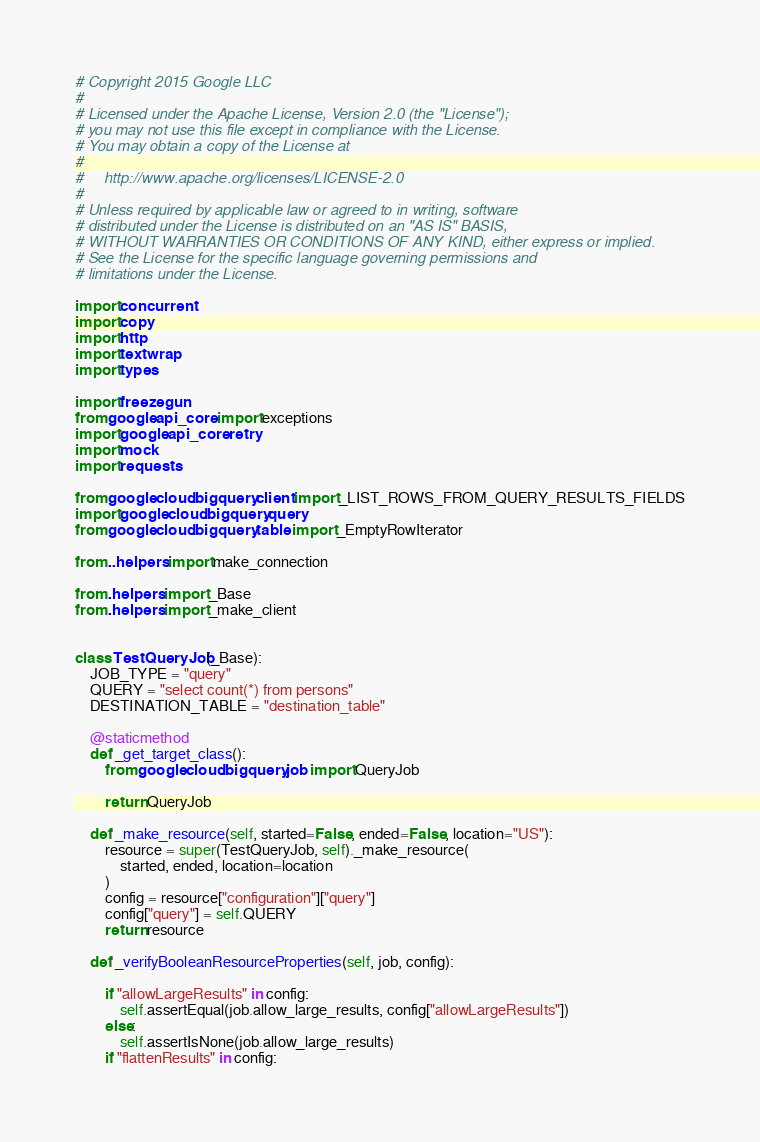<code> <loc_0><loc_0><loc_500><loc_500><_Python_># Copyright 2015 Google LLC
#
# Licensed under the Apache License, Version 2.0 (the "License");
# you may not use this file except in compliance with the License.
# You may obtain a copy of the License at
#
#     http://www.apache.org/licenses/LICENSE-2.0
#
# Unless required by applicable law or agreed to in writing, software
# distributed under the License is distributed on an "AS IS" BASIS,
# WITHOUT WARRANTIES OR CONDITIONS OF ANY KIND, either express or implied.
# See the License for the specific language governing permissions and
# limitations under the License.

import concurrent
import copy
import http
import textwrap
import types

import freezegun
from google.api_core import exceptions
import google.api_core.retry
import mock
import requests

from google.cloud.bigquery.client import _LIST_ROWS_FROM_QUERY_RESULTS_FIELDS
import google.cloud.bigquery.query
from google.cloud.bigquery.table import _EmptyRowIterator

from ..helpers import make_connection

from .helpers import _Base
from .helpers import _make_client


class TestQueryJob(_Base):
    JOB_TYPE = "query"
    QUERY = "select count(*) from persons"
    DESTINATION_TABLE = "destination_table"

    @staticmethod
    def _get_target_class():
        from google.cloud.bigquery.job import QueryJob

        return QueryJob

    def _make_resource(self, started=False, ended=False, location="US"):
        resource = super(TestQueryJob, self)._make_resource(
            started, ended, location=location
        )
        config = resource["configuration"]["query"]
        config["query"] = self.QUERY
        return resource

    def _verifyBooleanResourceProperties(self, job, config):

        if "allowLargeResults" in config:
            self.assertEqual(job.allow_large_results, config["allowLargeResults"])
        else:
            self.assertIsNone(job.allow_large_results)
        if "flattenResults" in config:</code> 